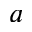<formula> <loc_0><loc_0><loc_500><loc_500>a</formula> 